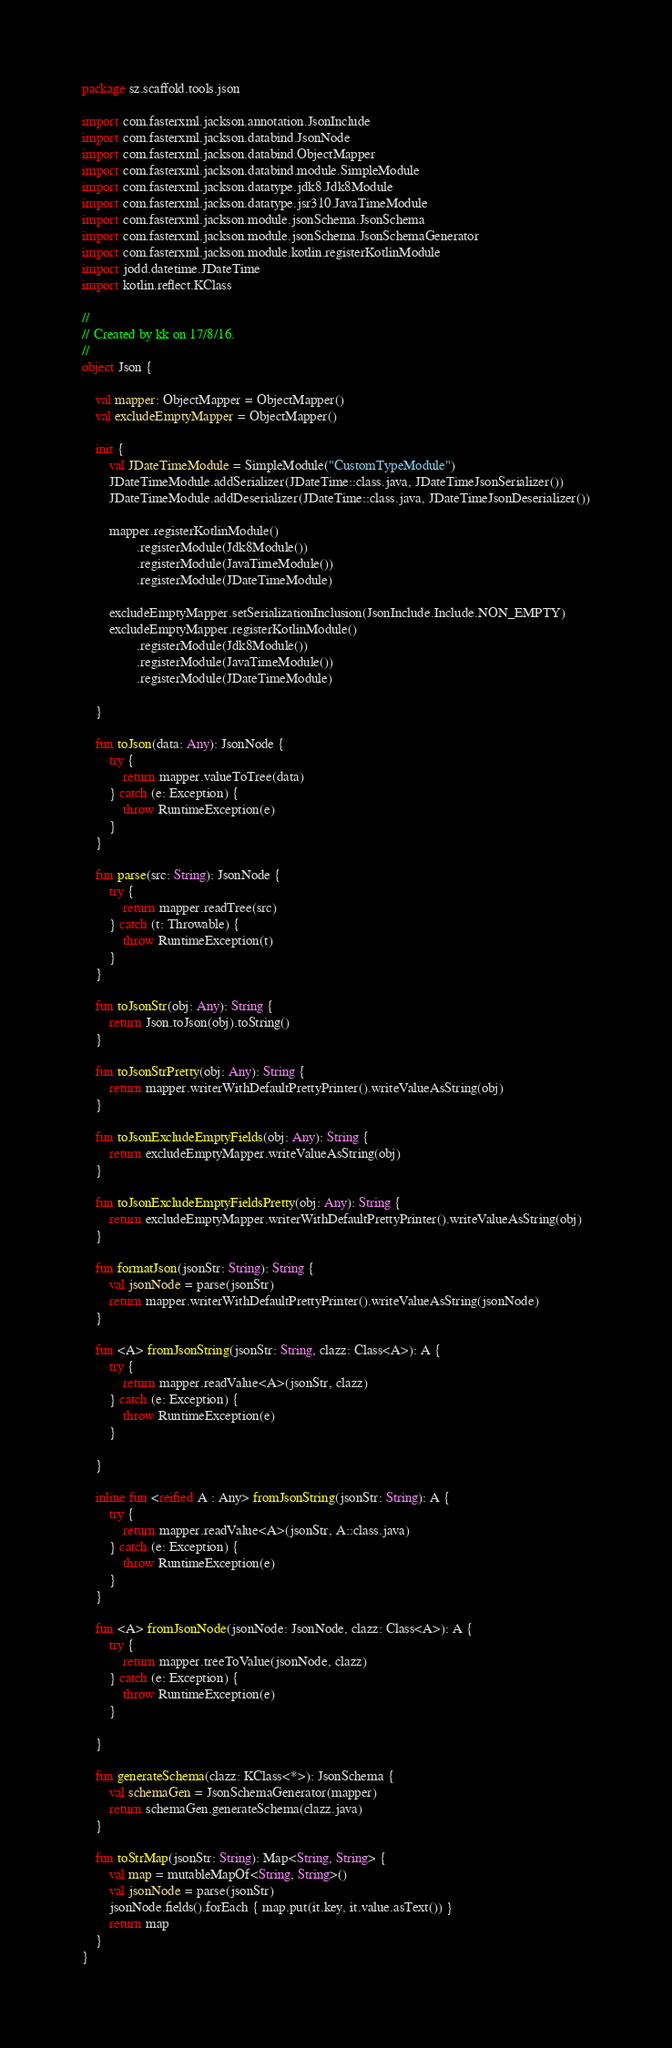Convert code to text. <code><loc_0><loc_0><loc_500><loc_500><_Kotlin_>package sz.scaffold.tools.json

import com.fasterxml.jackson.annotation.JsonInclude
import com.fasterxml.jackson.databind.JsonNode
import com.fasterxml.jackson.databind.ObjectMapper
import com.fasterxml.jackson.databind.module.SimpleModule
import com.fasterxml.jackson.datatype.jdk8.Jdk8Module
import com.fasterxml.jackson.datatype.jsr310.JavaTimeModule
import com.fasterxml.jackson.module.jsonSchema.JsonSchema
import com.fasterxml.jackson.module.jsonSchema.JsonSchemaGenerator
import com.fasterxml.jackson.module.kotlin.registerKotlinModule
import jodd.datetime.JDateTime
import kotlin.reflect.KClass

//
// Created by kk on 17/8/16.
//
object Json {

    val mapper: ObjectMapper = ObjectMapper()
    val excludeEmptyMapper = ObjectMapper()

    init {
        val JDateTimeModule = SimpleModule("CustomTypeModule")
        JDateTimeModule.addSerializer(JDateTime::class.java, JDateTimeJsonSerializer())
        JDateTimeModule.addDeserializer(JDateTime::class.java, JDateTimeJsonDeserializer())

        mapper.registerKotlinModule()
                .registerModule(Jdk8Module())
                .registerModule(JavaTimeModule())
                .registerModule(JDateTimeModule)

        excludeEmptyMapper.setSerializationInclusion(JsonInclude.Include.NON_EMPTY)
        excludeEmptyMapper.registerKotlinModule()
                .registerModule(Jdk8Module())
                .registerModule(JavaTimeModule())
                .registerModule(JDateTimeModule)

    }

    fun toJson(data: Any): JsonNode {
        try {
            return mapper.valueToTree(data)
        } catch (e: Exception) {
            throw RuntimeException(e)
        }
    }

    fun parse(src: String): JsonNode {
        try {
            return mapper.readTree(src)
        } catch (t: Throwable) {
            throw RuntimeException(t)
        }
    }

    fun toJsonStr(obj: Any): String {
        return Json.toJson(obj).toString()
    }

    fun toJsonStrPretty(obj: Any): String {
        return mapper.writerWithDefaultPrettyPrinter().writeValueAsString(obj)
    }

    fun toJsonExcludeEmptyFields(obj: Any): String {
        return excludeEmptyMapper.writeValueAsString(obj)
    }

    fun toJsonExcludeEmptyFieldsPretty(obj: Any): String {
        return excludeEmptyMapper.writerWithDefaultPrettyPrinter().writeValueAsString(obj)
    }

    fun formatJson(jsonStr: String): String {
        val jsonNode = parse(jsonStr)
        return mapper.writerWithDefaultPrettyPrinter().writeValueAsString(jsonNode)
    }

    fun <A> fromJsonString(jsonStr: String, clazz: Class<A>): A {
        try {
            return mapper.readValue<A>(jsonStr, clazz)
        } catch (e: Exception) {
            throw RuntimeException(e)
        }

    }

    inline fun <reified A : Any> fromJsonString(jsonStr: String): A {
        try {
            return mapper.readValue<A>(jsonStr, A::class.java)
        } catch (e: Exception) {
            throw RuntimeException(e)
        }
    }

    fun <A> fromJsonNode(jsonNode: JsonNode, clazz: Class<A>): A {
        try {
            return mapper.treeToValue(jsonNode, clazz)
        } catch (e: Exception) {
            throw RuntimeException(e)
        }

    }

    fun generateSchema(clazz: KClass<*>): JsonSchema {
        val schemaGen = JsonSchemaGenerator(mapper)
        return schemaGen.generateSchema(clazz.java)
    }

    fun toStrMap(jsonStr: String): Map<String, String> {
        val map = mutableMapOf<String, String>()
        val jsonNode = parse(jsonStr)
        jsonNode.fields().forEach { map.put(it.key, it.value.asText()) }
        return map
    }
}</code> 